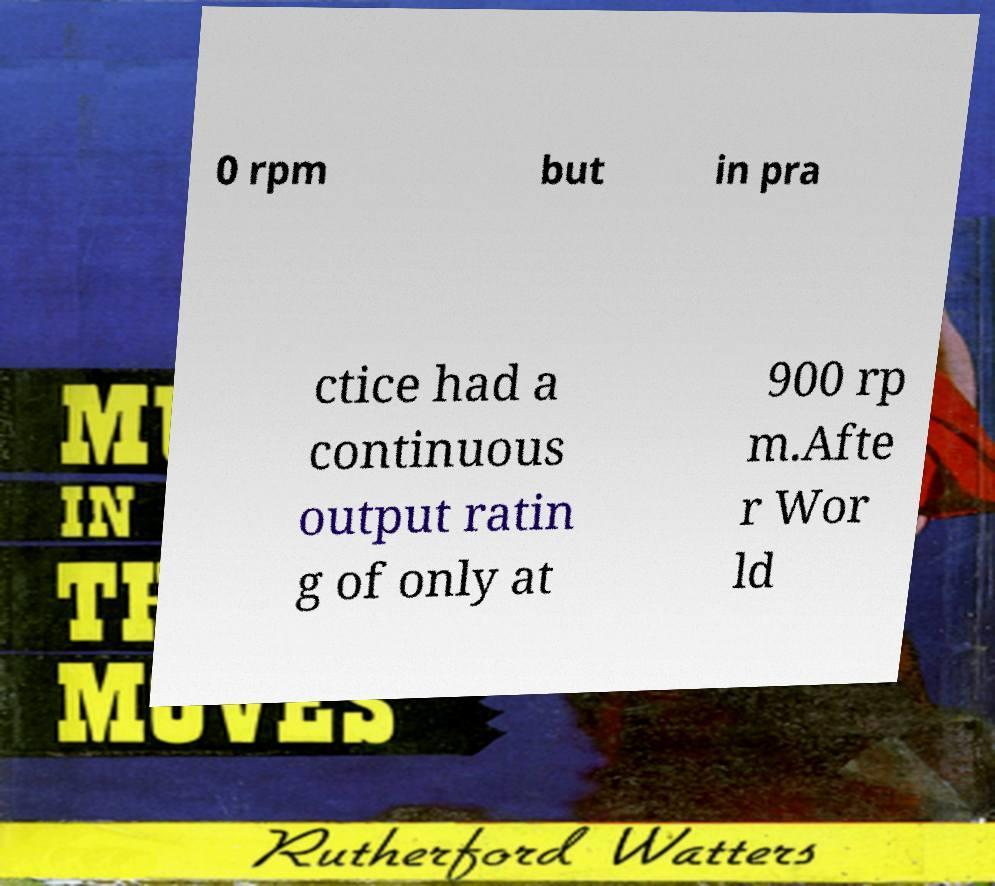What messages or text are displayed in this image? I need them in a readable, typed format. 0 rpm but in pra ctice had a continuous output ratin g of only at 900 rp m.Afte r Wor ld 